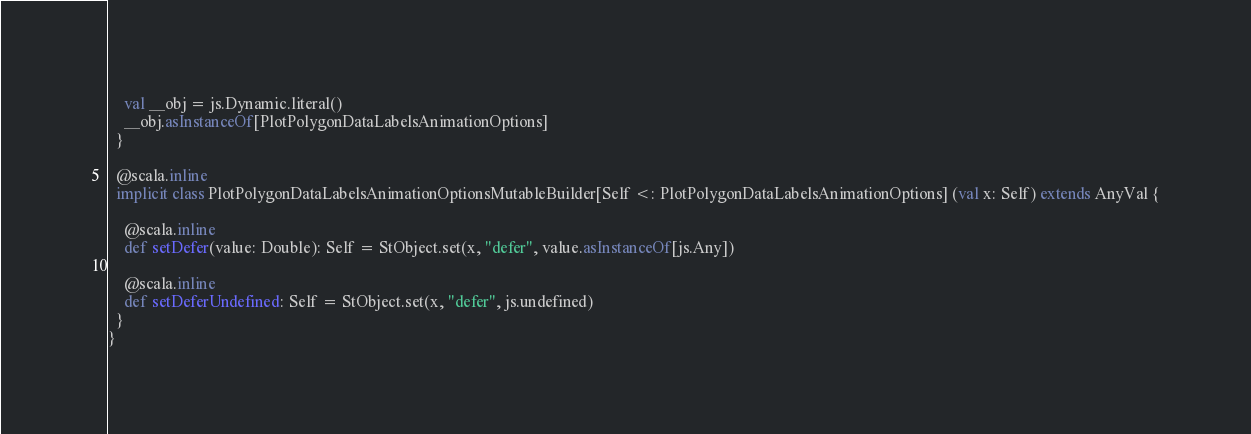<code> <loc_0><loc_0><loc_500><loc_500><_Scala_>    val __obj = js.Dynamic.literal()
    __obj.asInstanceOf[PlotPolygonDataLabelsAnimationOptions]
  }
  
  @scala.inline
  implicit class PlotPolygonDataLabelsAnimationOptionsMutableBuilder[Self <: PlotPolygonDataLabelsAnimationOptions] (val x: Self) extends AnyVal {
    
    @scala.inline
    def setDefer(value: Double): Self = StObject.set(x, "defer", value.asInstanceOf[js.Any])
    
    @scala.inline
    def setDeferUndefined: Self = StObject.set(x, "defer", js.undefined)
  }
}
</code> 